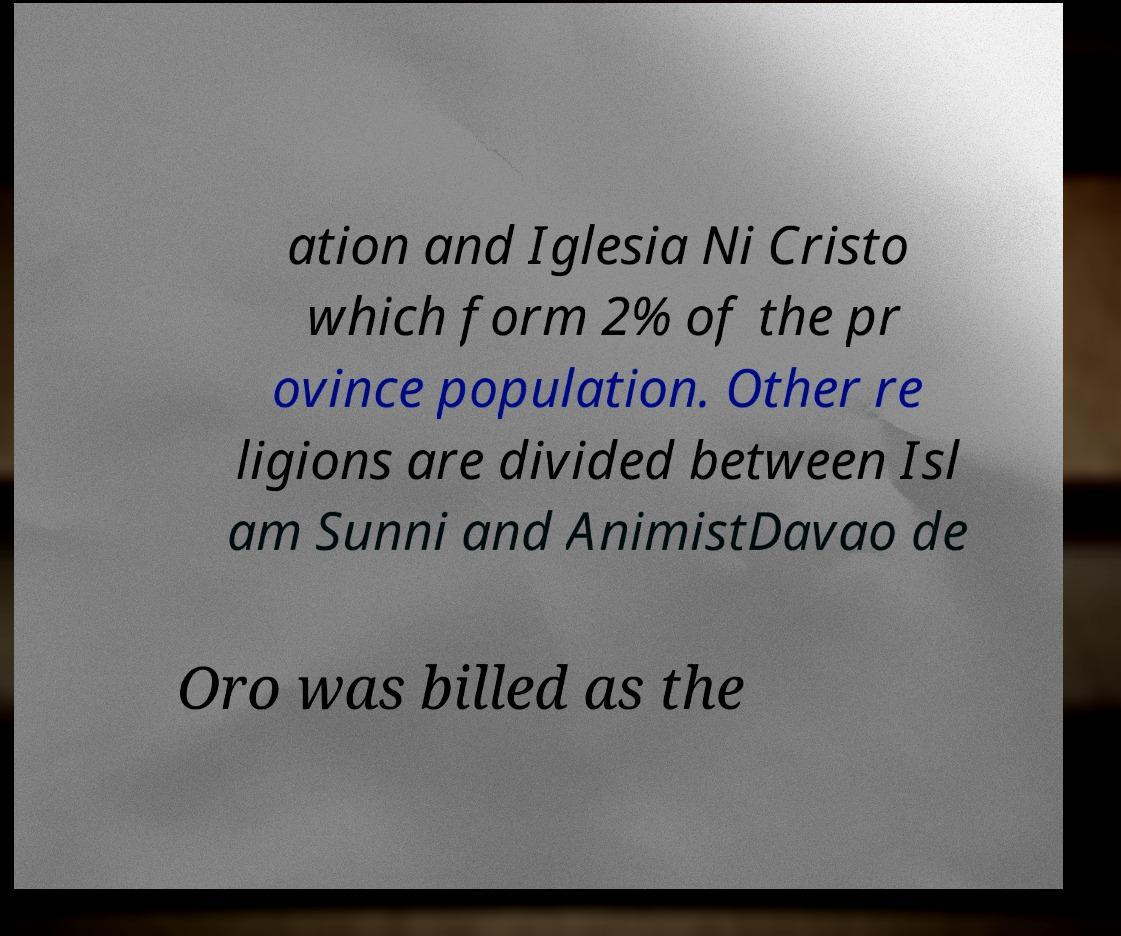Could you assist in decoding the text presented in this image and type it out clearly? ation and Iglesia Ni Cristo which form 2% of the pr ovince population. Other re ligions are divided between Isl am Sunni and AnimistDavao de Oro was billed as the 